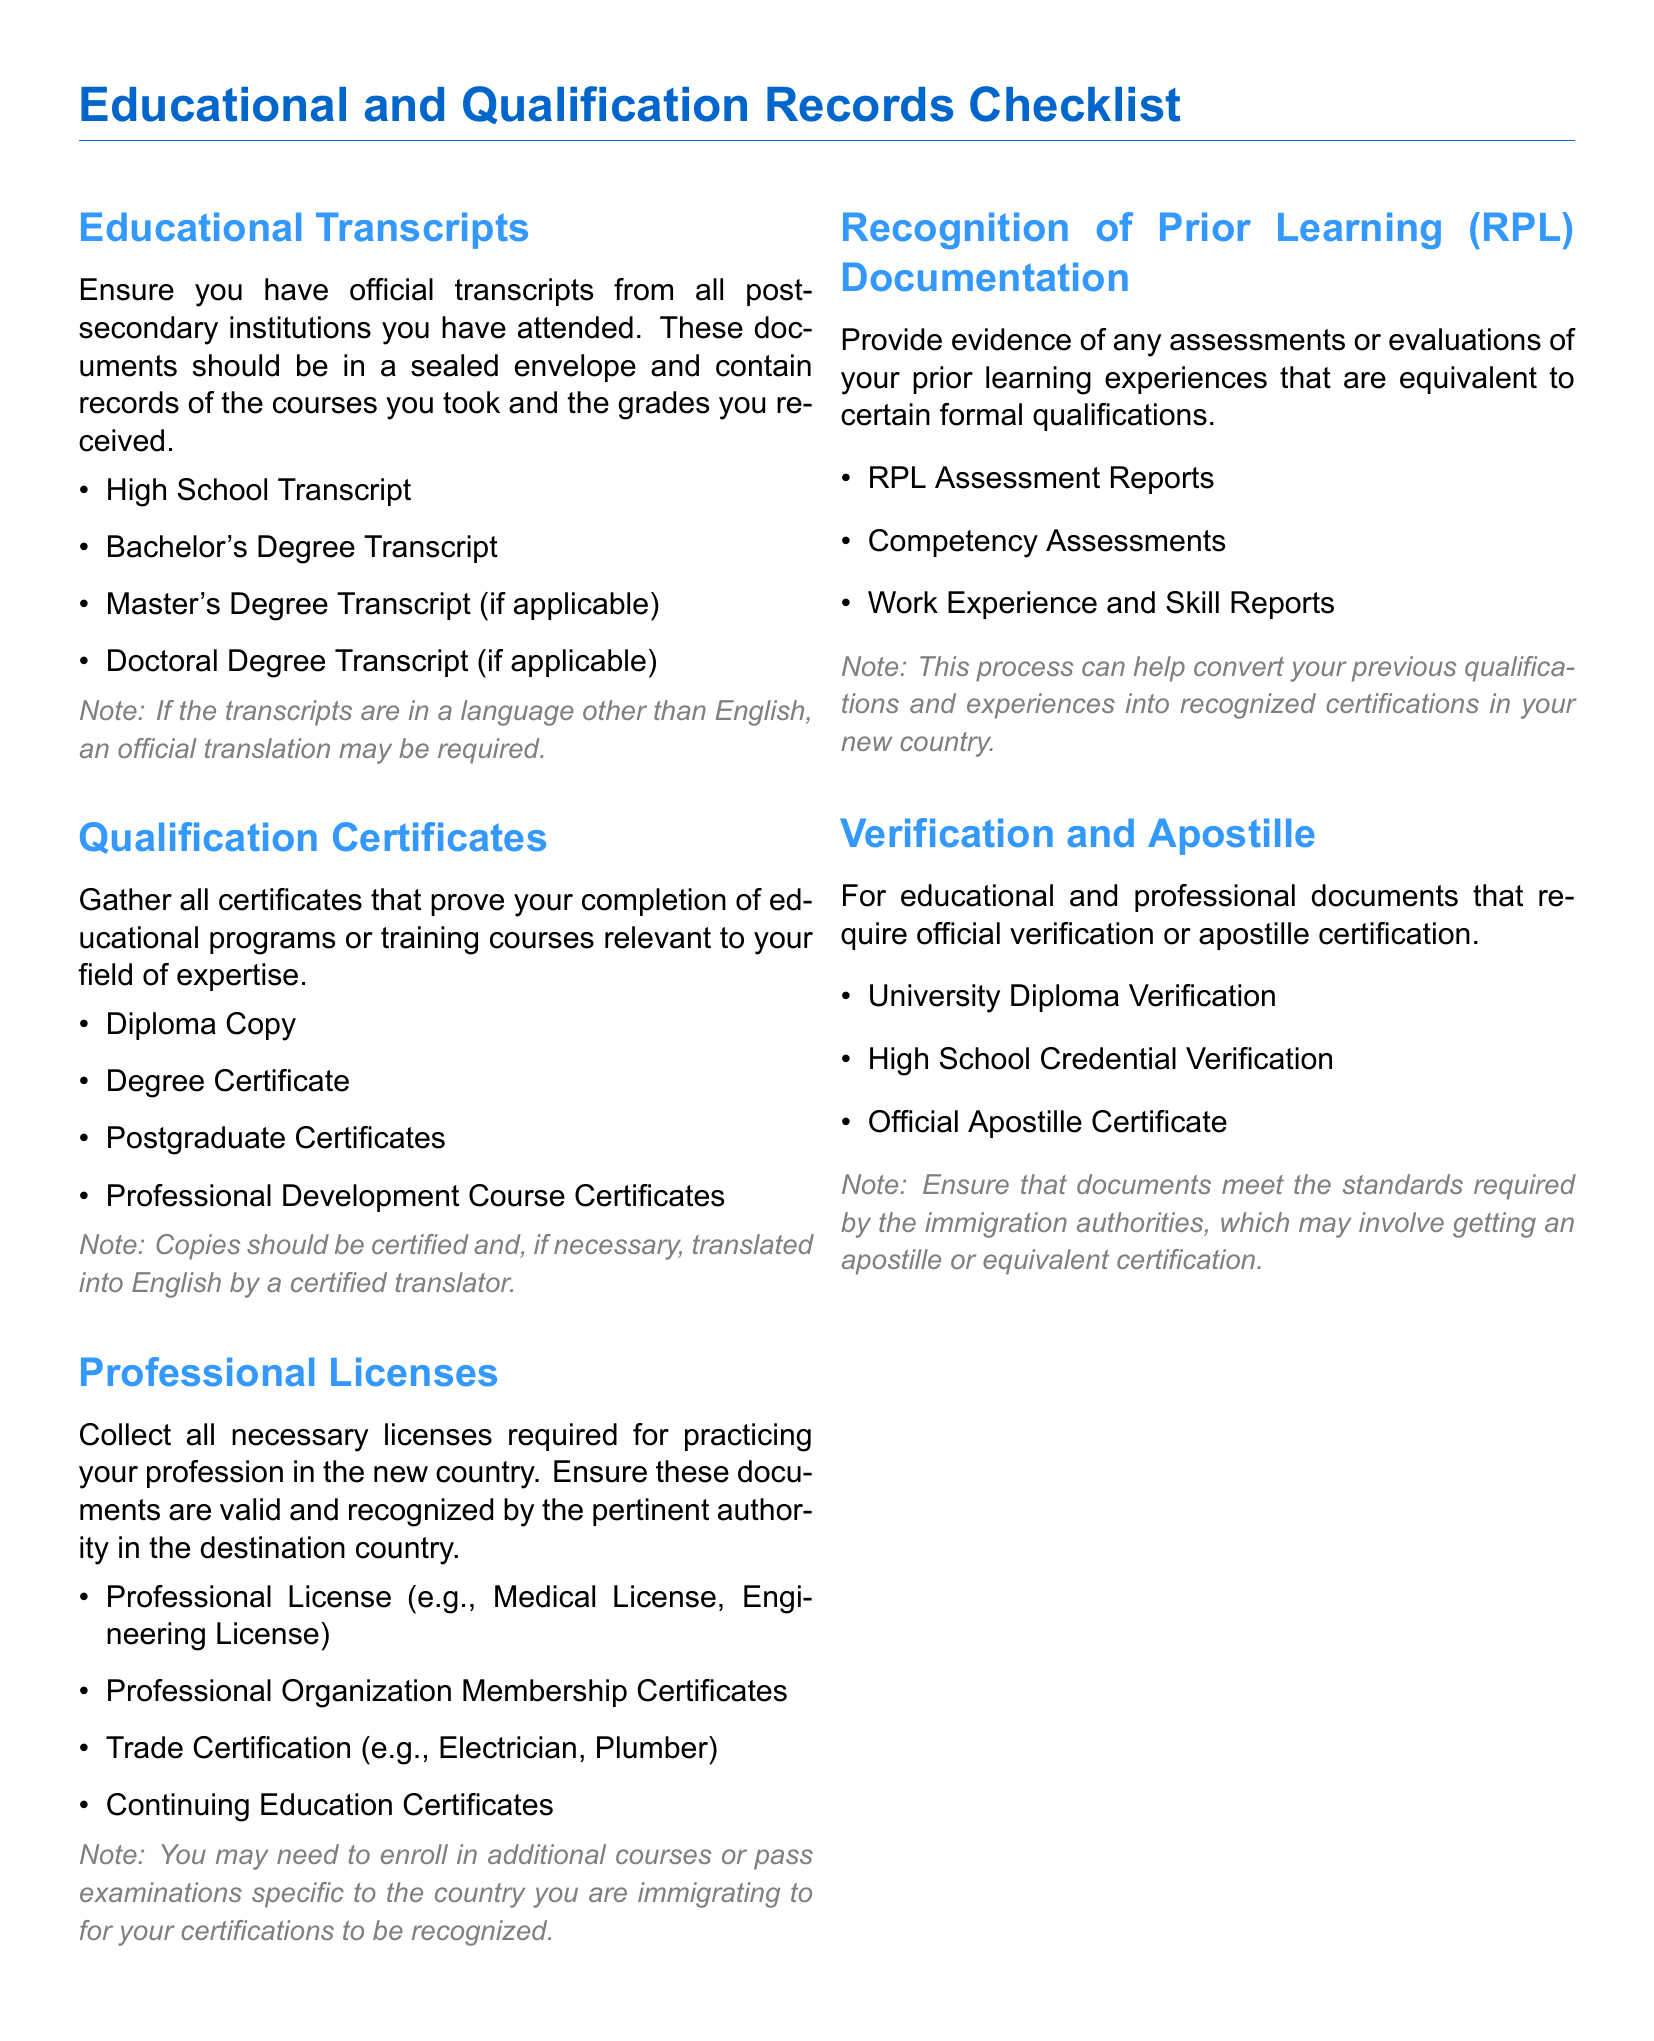What is required from post-secondary institutions? Official transcripts are required from all post-secondary institutions attended, in a sealed envelope.
Answer: Official transcripts How many types of transcripts are listed? The document lists four types of transcripts: High School, Bachelor's, Master's, and Doctoral.
Answer: Four Which document is necessary for verifying educational credentials? The University Diploma Verification is necessary for verifying educational credentials.
Answer: University Diploma Verification What type of certificates should be gathered? All certificates that prove completion of educational programs or training courses relevant to your field.
Answer: Qualification Certificates What may be needed for recognition of prior learning documentation? Evidence of assessments or evaluations equivalent to formal qualifications are needed for RPL documentation.
Answer: RPL Assessment Reports Are translations required for transcripts in a different language? Yes, an official translation may be required if transcripts are in a language other than English.
Answer: Yes How many items are listed under Professional Licenses? There are four items listed under Professional Licenses.
Answer: Four What type of verification might be necessary for educational documents? Official Apostille Certificate may be necessary for educational documents.
Answer: Official Apostille Certificate What may be required to convert previous qualifications? Enrolling in additional courses or passing examinations may be required to recognize previous qualifications.
Answer: Additional courses or examinations 